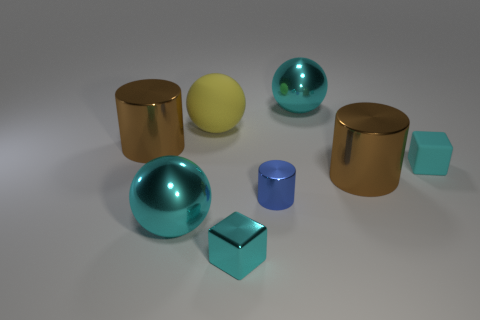Subtract all rubber balls. How many balls are left? 2 Add 1 small cubes. How many objects exist? 9 Subtract all blocks. How many objects are left? 6 Add 3 yellow matte objects. How many yellow matte objects are left? 4 Add 7 cyan balls. How many cyan balls exist? 9 Subtract 0 yellow cubes. How many objects are left? 8 Subtract all large shiny cylinders. Subtract all small cyan matte blocks. How many objects are left? 5 